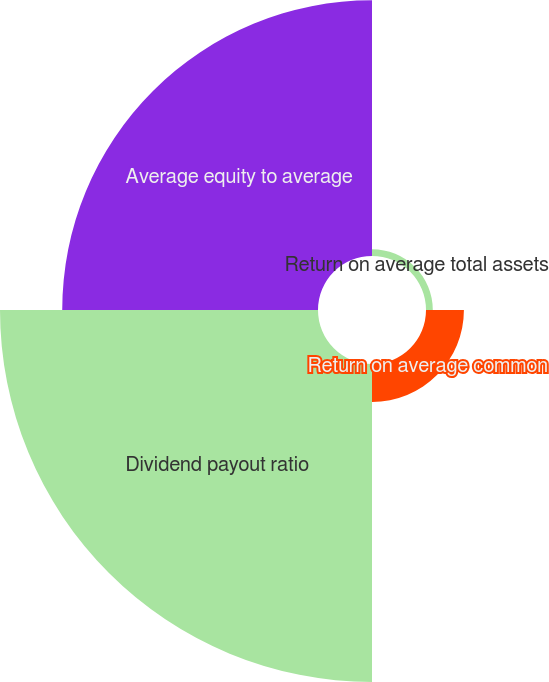<chart> <loc_0><loc_0><loc_500><loc_500><pie_chart><fcel>Return on average total assets<fcel>Return on average common<fcel>Dividend payout ratio<fcel>Average equity to average<nl><fcel>1.1%<fcel>6.13%<fcel>51.41%<fcel>41.35%<nl></chart> 